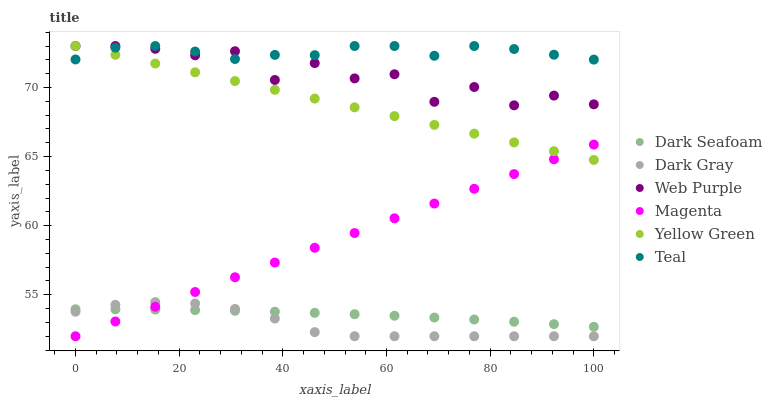Does Dark Gray have the minimum area under the curve?
Answer yes or no. Yes. Does Teal have the maximum area under the curve?
Answer yes or no. Yes. Does Web Purple have the minimum area under the curve?
Answer yes or no. No. Does Web Purple have the maximum area under the curve?
Answer yes or no. No. Is Yellow Green the smoothest?
Answer yes or no. Yes. Is Web Purple the roughest?
Answer yes or no. Yes. Is Dark Gray the smoothest?
Answer yes or no. No. Is Dark Gray the roughest?
Answer yes or no. No. Does Dark Gray have the lowest value?
Answer yes or no. Yes. Does Web Purple have the lowest value?
Answer yes or no. No. Does Teal have the highest value?
Answer yes or no. Yes. Does Dark Gray have the highest value?
Answer yes or no. No. Is Magenta less than Web Purple?
Answer yes or no. Yes. Is Teal greater than Magenta?
Answer yes or no. Yes. Does Dark Seafoam intersect Magenta?
Answer yes or no. Yes. Is Dark Seafoam less than Magenta?
Answer yes or no. No. Is Dark Seafoam greater than Magenta?
Answer yes or no. No. Does Magenta intersect Web Purple?
Answer yes or no. No. 